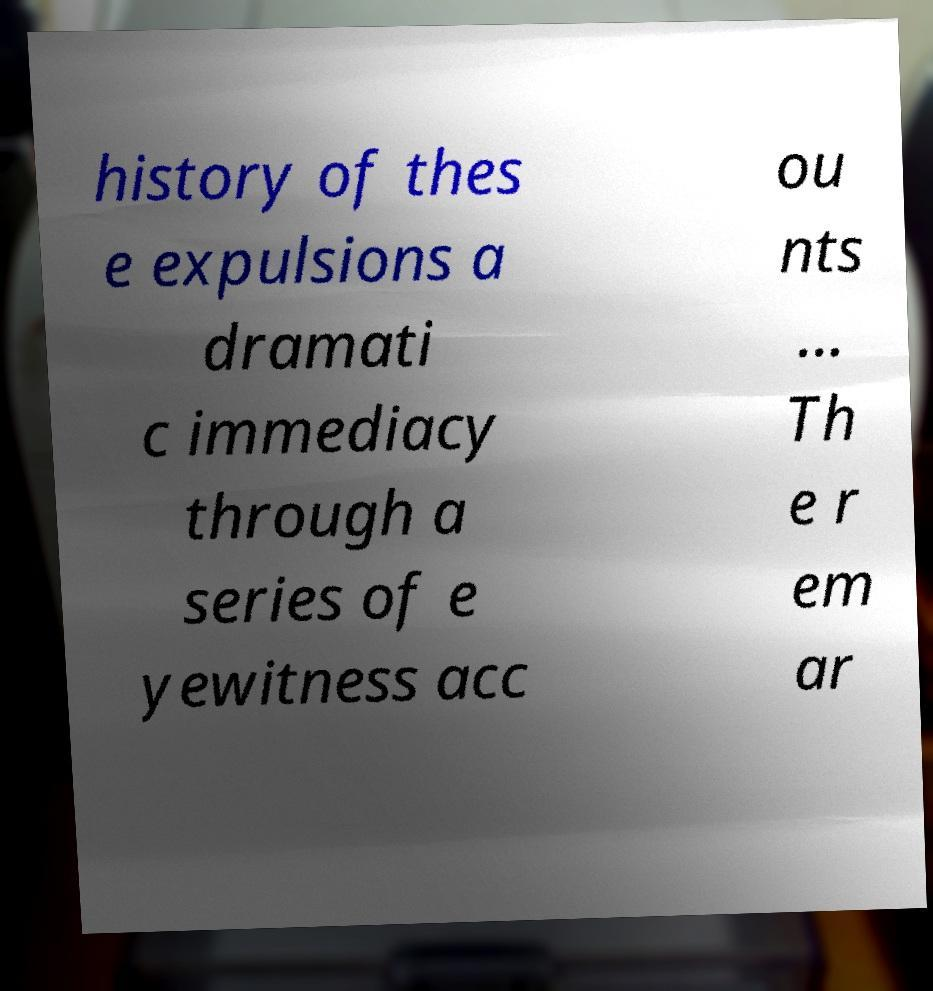Can you read and provide the text displayed in the image?This photo seems to have some interesting text. Can you extract and type it out for me? history of thes e expulsions a dramati c immediacy through a series of e yewitness acc ou nts ... Th e r em ar 